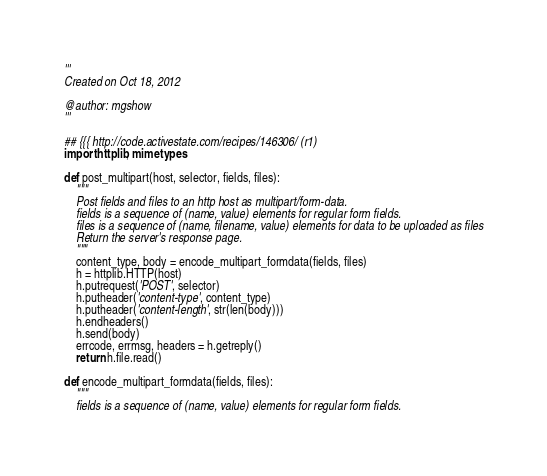Convert code to text. <code><loc_0><loc_0><loc_500><loc_500><_Python_>'''
Created on Oct 18, 2012

@author: mgshow
'''

## {{{ http://code.activestate.com/recipes/146306/ (r1)
import httplib, mimetypes

def post_multipart(host, selector, fields, files):
    """
    Post fields and files to an http host as multipart/form-data.
    fields is a sequence of (name, value) elements for regular form fields.
    files is a sequence of (name, filename, value) elements for data to be uploaded as files
    Return the server's response page.
    """
    content_type, body = encode_multipart_formdata(fields, files)
    h = httplib.HTTP(host)
    h.putrequest('POST', selector)
    h.putheader('content-type', content_type)
    h.putheader('content-length', str(len(body)))
    h.endheaders()
    h.send(body)
    errcode, errmsg, headers = h.getreply()
    return h.file.read()

def encode_multipart_formdata(fields, files):
    """
    fields is a sequence of (name, value) elements for regular form fields.</code> 